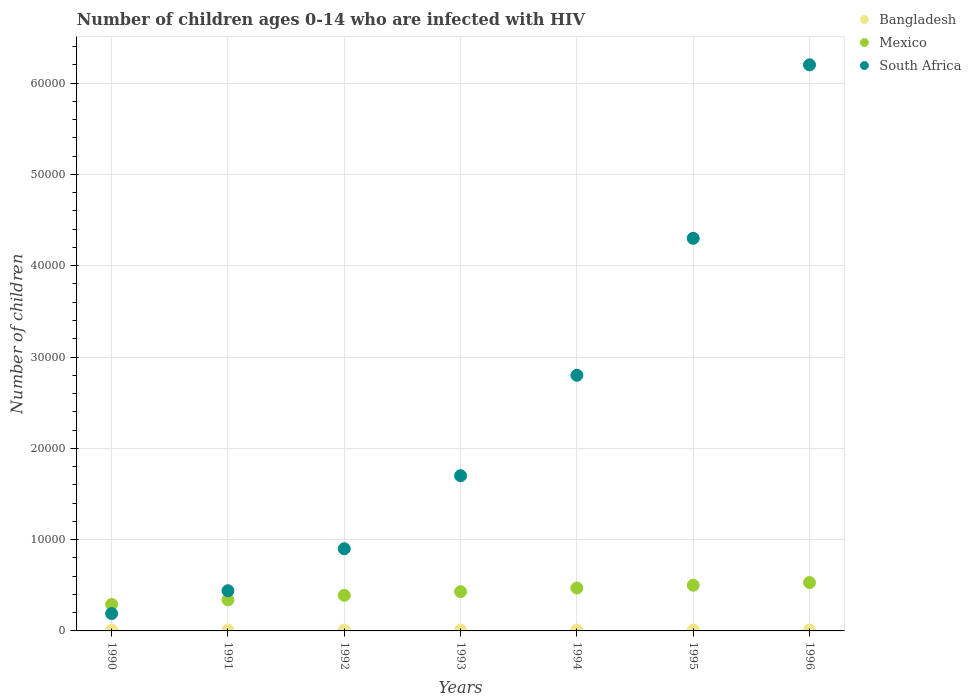What is the number of HIV infected children in South Africa in 1991?
Offer a very short reply. 4400. Across all years, what is the maximum number of HIV infected children in Mexico?
Keep it short and to the point. 5300. Across all years, what is the minimum number of HIV infected children in Bangladesh?
Offer a terse response. 100. What is the total number of HIV infected children in Bangladesh in the graph?
Make the answer very short. 700. What is the difference between the number of HIV infected children in Mexico in 1992 and that in 1995?
Your response must be concise. -1100. What is the difference between the number of HIV infected children in South Africa in 1991 and the number of HIV infected children in Mexico in 1992?
Your answer should be compact. 500. What is the average number of HIV infected children in South Africa per year?
Give a very brief answer. 2.36e+04. In the year 1994, what is the difference between the number of HIV infected children in South Africa and number of HIV infected children in Mexico?
Ensure brevity in your answer.  2.33e+04. In how many years, is the number of HIV infected children in Mexico greater than 50000?
Give a very brief answer. 0. What is the ratio of the number of HIV infected children in Bangladesh in 1990 to that in 1993?
Your answer should be very brief. 1. What is the difference between the highest and the second highest number of HIV infected children in Mexico?
Your response must be concise. 300. What is the difference between the highest and the lowest number of HIV infected children in Mexico?
Provide a short and direct response. 2400. Is the sum of the number of HIV infected children in Mexico in 1990 and 1996 greater than the maximum number of HIV infected children in South Africa across all years?
Your response must be concise. No. Is it the case that in every year, the sum of the number of HIV infected children in Mexico and number of HIV infected children in Bangladesh  is greater than the number of HIV infected children in South Africa?
Make the answer very short. No. Does the number of HIV infected children in Mexico monotonically increase over the years?
Offer a terse response. Yes. Is the number of HIV infected children in Bangladesh strictly less than the number of HIV infected children in South Africa over the years?
Your answer should be compact. Yes. Does the graph contain any zero values?
Provide a short and direct response. No. Does the graph contain grids?
Offer a terse response. Yes. Where does the legend appear in the graph?
Offer a very short reply. Top right. How many legend labels are there?
Offer a very short reply. 3. How are the legend labels stacked?
Give a very brief answer. Vertical. What is the title of the graph?
Provide a short and direct response. Number of children ages 0-14 who are infected with HIV. What is the label or title of the X-axis?
Provide a succinct answer. Years. What is the label or title of the Y-axis?
Ensure brevity in your answer.  Number of children. What is the Number of children in Bangladesh in 1990?
Your answer should be compact. 100. What is the Number of children in Mexico in 1990?
Your response must be concise. 2900. What is the Number of children of South Africa in 1990?
Offer a very short reply. 1900. What is the Number of children in Mexico in 1991?
Your answer should be very brief. 3400. What is the Number of children of South Africa in 1991?
Provide a short and direct response. 4400. What is the Number of children of Mexico in 1992?
Your answer should be very brief. 3900. What is the Number of children in South Africa in 1992?
Give a very brief answer. 9000. What is the Number of children in Bangladesh in 1993?
Provide a short and direct response. 100. What is the Number of children of Mexico in 1993?
Provide a short and direct response. 4300. What is the Number of children in South Africa in 1993?
Give a very brief answer. 1.70e+04. What is the Number of children in Bangladesh in 1994?
Offer a very short reply. 100. What is the Number of children in Mexico in 1994?
Provide a succinct answer. 4700. What is the Number of children in South Africa in 1994?
Offer a very short reply. 2.80e+04. What is the Number of children of Bangladesh in 1995?
Provide a succinct answer. 100. What is the Number of children of South Africa in 1995?
Your answer should be very brief. 4.30e+04. What is the Number of children of Mexico in 1996?
Give a very brief answer. 5300. What is the Number of children of South Africa in 1996?
Your answer should be compact. 6.20e+04. Across all years, what is the maximum Number of children of Bangladesh?
Offer a very short reply. 100. Across all years, what is the maximum Number of children of Mexico?
Your answer should be compact. 5300. Across all years, what is the maximum Number of children in South Africa?
Give a very brief answer. 6.20e+04. Across all years, what is the minimum Number of children of Bangladesh?
Keep it short and to the point. 100. Across all years, what is the minimum Number of children of Mexico?
Your answer should be very brief. 2900. Across all years, what is the minimum Number of children of South Africa?
Provide a succinct answer. 1900. What is the total Number of children of Bangladesh in the graph?
Provide a succinct answer. 700. What is the total Number of children in Mexico in the graph?
Offer a very short reply. 2.95e+04. What is the total Number of children of South Africa in the graph?
Your answer should be very brief. 1.65e+05. What is the difference between the Number of children in Mexico in 1990 and that in 1991?
Offer a very short reply. -500. What is the difference between the Number of children in South Africa in 1990 and that in 1991?
Ensure brevity in your answer.  -2500. What is the difference between the Number of children in Mexico in 1990 and that in 1992?
Give a very brief answer. -1000. What is the difference between the Number of children in South Africa in 1990 and that in 1992?
Make the answer very short. -7100. What is the difference between the Number of children in Mexico in 1990 and that in 1993?
Your answer should be compact. -1400. What is the difference between the Number of children of South Africa in 1990 and that in 1993?
Offer a very short reply. -1.51e+04. What is the difference between the Number of children of Bangladesh in 1990 and that in 1994?
Offer a terse response. 0. What is the difference between the Number of children of Mexico in 1990 and that in 1994?
Your answer should be very brief. -1800. What is the difference between the Number of children of South Africa in 1990 and that in 1994?
Provide a short and direct response. -2.61e+04. What is the difference between the Number of children in Bangladesh in 1990 and that in 1995?
Offer a very short reply. 0. What is the difference between the Number of children of Mexico in 1990 and that in 1995?
Your response must be concise. -2100. What is the difference between the Number of children of South Africa in 1990 and that in 1995?
Ensure brevity in your answer.  -4.11e+04. What is the difference between the Number of children in Mexico in 1990 and that in 1996?
Make the answer very short. -2400. What is the difference between the Number of children of South Africa in 1990 and that in 1996?
Provide a short and direct response. -6.01e+04. What is the difference between the Number of children in Mexico in 1991 and that in 1992?
Keep it short and to the point. -500. What is the difference between the Number of children of South Africa in 1991 and that in 1992?
Your answer should be very brief. -4600. What is the difference between the Number of children in Bangladesh in 1991 and that in 1993?
Offer a very short reply. 0. What is the difference between the Number of children of Mexico in 1991 and that in 1993?
Offer a terse response. -900. What is the difference between the Number of children in South Africa in 1991 and that in 1993?
Ensure brevity in your answer.  -1.26e+04. What is the difference between the Number of children of Bangladesh in 1991 and that in 1994?
Your response must be concise. 0. What is the difference between the Number of children in Mexico in 1991 and that in 1994?
Make the answer very short. -1300. What is the difference between the Number of children of South Africa in 1991 and that in 1994?
Your answer should be compact. -2.36e+04. What is the difference between the Number of children of Mexico in 1991 and that in 1995?
Ensure brevity in your answer.  -1600. What is the difference between the Number of children in South Africa in 1991 and that in 1995?
Keep it short and to the point. -3.86e+04. What is the difference between the Number of children in Bangladesh in 1991 and that in 1996?
Ensure brevity in your answer.  0. What is the difference between the Number of children of Mexico in 1991 and that in 1996?
Provide a short and direct response. -1900. What is the difference between the Number of children of South Africa in 1991 and that in 1996?
Ensure brevity in your answer.  -5.76e+04. What is the difference between the Number of children of Mexico in 1992 and that in 1993?
Offer a terse response. -400. What is the difference between the Number of children in South Africa in 1992 and that in 1993?
Your response must be concise. -8000. What is the difference between the Number of children in Bangladesh in 1992 and that in 1994?
Your answer should be very brief. 0. What is the difference between the Number of children in Mexico in 1992 and that in 1994?
Make the answer very short. -800. What is the difference between the Number of children in South Africa in 1992 and that in 1994?
Offer a very short reply. -1.90e+04. What is the difference between the Number of children of Mexico in 1992 and that in 1995?
Keep it short and to the point. -1100. What is the difference between the Number of children of South Africa in 1992 and that in 1995?
Offer a terse response. -3.40e+04. What is the difference between the Number of children of Mexico in 1992 and that in 1996?
Your response must be concise. -1400. What is the difference between the Number of children in South Africa in 1992 and that in 1996?
Provide a short and direct response. -5.30e+04. What is the difference between the Number of children in Bangladesh in 1993 and that in 1994?
Make the answer very short. 0. What is the difference between the Number of children of Mexico in 1993 and that in 1994?
Your answer should be compact. -400. What is the difference between the Number of children in South Africa in 1993 and that in 1994?
Give a very brief answer. -1.10e+04. What is the difference between the Number of children in Bangladesh in 1993 and that in 1995?
Your response must be concise. 0. What is the difference between the Number of children of Mexico in 1993 and that in 1995?
Provide a succinct answer. -700. What is the difference between the Number of children in South Africa in 1993 and that in 1995?
Ensure brevity in your answer.  -2.60e+04. What is the difference between the Number of children of Mexico in 1993 and that in 1996?
Your response must be concise. -1000. What is the difference between the Number of children of South Africa in 1993 and that in 1996?
Provide a short and direct response. -4.50e+04. What is the difference between the Number of children in Bangladesh in 1994 and that in 1995?
Your response must be concise. 0. What is the difference between the Number of children in Mexico in 1994 and that in 1995?
Ensure brevity in your answer.  -300. What is the difference between the Number of children in South Africa in 1994 and that in 1995?
Provide a succinct answer. -1.50e+04. What is the difference between the Number of children of Mexico in 1994 and that in 1996?
Offer a very short reply. -600. What is the difference between the Number of children of South Africa in 1994 and that in 1996?
Your response must be concise. -3.40e+04. What is the difference between the Number of children in Bangladesh in 1995 and that in 1996?
Offer a terse response. 0. What is the difference between the Number of children of Mexico in 1995 and that in 1996?
Offer a very short reply. -300. What is the difference between the Number of children of South Africa in 1995 and that in 1996?
Provide a succinct answer. -1.90e+04. What is the difference between the Number of children in Bangladesh in 1990 and the Number of children in Mexico in 1991?
Provide a short and direct response. -3300. What is the difference between the Number of children in Bangladesh in 1990 and the Number of children in South Africa in 1991?
Offer a terse response. -4300. What is the difference between the Number of children in Mexico in 1990 and the Number of children in South Africa in 1991?
Ensure brevity in your answer.  -1500. What is the difference between the Number of children of Bangladesh in 1990 and the Number of children of Mexico in 1992?
Provide a succinct answer. -3800. What is the difference between the Number of children of Bangladesh in 1990 and the Number of children of South Africa in 1992?
Your response must be concise. -8900. What is the difference between the Number of children in Mexico in 1990 and the Number of children in South Africa in 1992?
Give a very brief answer. -6100. What is the difference between the Number of children in Bangladesh in 1990 and the Number of children in Mexico in 1993?
Provide a succinct answer. -4200. What is the difference between the Number of children of Bangladesh in 1990 and the Number of children of South Africa in 1993?
Give a very brief answer. -1.69e+04. What is the difference between the Number of children in Mexico in 1990 and the Number of children in South Africa in 1993?
Offer a terse response. -1.41e+04. What is the difference between the Number of children in Bangladesh in 1990 and the Number of children in Mexico in 1994?
Your answer should be very brief. -4600. What is the difference between the Number of children in Bangladesh in 1990 and the Number of children in South Africa in 1994?
Your answer should be very brief. -2.79e+04. What is the difference between the Number of children of Mexico in 1990 and the Number of children of South Africa in 1994?
Provide a short and direct response. -2.51e+04. What is the difference between the Number of children of Bangladesh in 1990 and the Number of children of Mexico in 1995?
Give a very brief answer. -4900. What is the difference between the Number of children in Bangladesh in 1990 and the Number of children in South Africa in 1995?
Provide a short and direct response. -4.29e+04. What is the difference between the Number of children of Mexico in 1990 and the Number of children of South Africa in 1995?
Offer a terse response. -4.01e+04. What is the difference between the Number of children in Bangladesh in 1990 and the Number of children in Mexico in 1996?
Offer a very short reply. -5200. What is the difference between the Number of children in Bangladesh in 1990 and the Number of children in South Africa in 1996?
Give a very brief answer. -6.19e+04. What is the difference between the Number of children of Mexico in 1990 and the Number of children of South Africa in 1996?
Your answer should be compact. -5.91e+04. What is the difference between the Number of children in Bangladesh in 1991 and the Number of children in Mexico in 1992?
Give a very brief answer. -3800. What is the difference between the Number of children in Bangladesh in 1991 and the Number of children in South Africa in 1992?
Provide a succinct answer. -8900. What is the difference between the Number of children in Mexico in 1991 and the Number of children in South Africa in 1992?
Your answer should be compact. -5600. What is the difference between the Number of children in Bangladesh in 1991 and the Number of children in Mexico in 1993?
Give a very brief answer. -4200. What is the difference between the Number of children of Bangladesh in 1991 and the Number of children of South Africa in 1993?
Ensure brevity in your answer.  -1.69e+04. What is the difference between the Number of children in Mexico in 1991 and the Number of children in South Africa in 1993?
Provide a short and direct response. -1.36e+04. What is the difference between the Number of children of Bangladesh in 1991 and the Number of children of Mexico in 1994?
Provide a succinct answer. -4600. What is the difference between the Number of children of Bangladesh in 1991 and the Number of children of South Africa in 1994?
Offer a terse response. -2.79e+04. What is the difference between the Number of children of Mexico in 1991 and the Number of children of South Africa in 1994?
Offer a terse response. -2.46e+04. What is the difference between the Number of children in Bangladesh in 1991 and the Number of children in Mexico in 1995?
Offer a terse response. -4900. What is the difference between the Number of children of Bangladesh in 1991 and the Number of children of South Africa in 1995?
Offer a terse response. -4.29e+04. What is the difference between the Number of children of Mexico in 1991 and the Number of children of South Africa in 1995?
Provide a succinct answer. -3.96e+04. What is the difference between the Number of children in Bangladesh in 1991 and the Number of children in Mexico in 1996?
Your answer should be compact. -5200. What is the difference between the Number of children of Bangladesh in 1991 and the Number of children of South Africa in 1996?
Make the answer very short. -6.19e+04. What is the difference between the Number of children in Mexico in 1991 and the Number of children in South Africa in 1996?
Your answer should be very brief. -5.86e+04. What is the difference between the Number of children of Bangladesh in 1992 and the Number of children of Mexico in 1993?
Offer a terse response. -4200. What is the difference between the Number of children of Bangladesh in 1992 and the Number of children of South Africa in 1993?
Offer a terse response. -1.69e+04. What is the difference between the Number of children of Mexico in 1992 and the Number of children of South Africa in 1993?
Offer a terse response. -1.31e+04. What is the difference between the Number of children in Bangladesh in 1992 and the Number of children in Mexico in 1994?
Offer a terse response. -4600. What is the difference between the Number of children of Bangladesh in 1992 and the Number of children of South Africa in 1994?
Provide a succinct answer. -2.79e+04. What is the difference between the Number of children of Mexico in 1992 and the Number of children of South Africa in 1994?
Provide a succinct answer. -2.41e+04. What is the difference between the Number of children in Bangladesh in 1992 and the Number of children in Mexico in 1995?
Your response must be concise. -4900. What is the difference between the Number of children of Bangladesh in 1992 and the Number of children of South Africa in 1995?
Make the answer very short. -4.29e+04. What is the difference between the Number of children of Mexico in 1992 and the Number of children of South Africa in 1995?
Offer a very short reply. -3.91e+04. What is the difference between the Number of children of Bangladesh in 1992 and the Number of children of Mexico in 1996?
Offer a terse response. -5200. What is the difference between the Number of children in Bangladesh in 1992 and the Number of children in South Africa in 1996?
Your answer should be very brief. -6.19e+04. What is the difference between the Number of children in Mexico in 1992 and the Number of children in South Africa in 1996?
Your answer should be very brief. -5.81e+04. What is the difference between the Number of children of Bangladesh in 1993 and the Number of children of Mexico in 1994?
Make the answer very short. -4600. What is the difference between the Number of children in Bangladesh in 1993 and the Number of children in South Africa in 1994?
Make the answer very short. -2.79e+04. What is the difference between the Number of children in Mexico in 1993 and the Number of children in South Africa in 1994?
Make the answer very short. -2.37e+04. What is the difference between the Number of children in Bangladesh in 1993 and the Number of children in Mexico in 1995?
Provide a succinct answer. -4900. What is the difference between the Number of children in Bangladesh in 1993 and the Number of children in South Africa in 1995?
Ensure brevity in your answer.  -4.29e+04. What is the difference between the Number of children of Mexico in 1993 and the Number of children of South Africa in 1995?
Your response must be concise. -3.87e+04. What is the difference between the Number of children of Bangladesh in 1993 and the Number of children of Mexico in 1996?
Provide a succinct answer. -5200. What is the difference between the Number of children in Bangladesh in 1993 and the Number of children in South Africa in 1996?
Your response must be concise. -6.19e+04. What is the difference between the Number of children in Mexico in 1993 and the Number of children in South Africa in 1996?
Your response must be concise. -5.77e+04. What is the difference between the Number of children of Bangladesh in 1994 and the Number of children of Mexico in 1995?
Provide a short and direct response. -4900. What is the difference between the Number of children of Bangladesh in 1994 and the Number of children of South Africa in 1995?
Give a very brief answer. -4.29e+04. What is the difference between the Number of children in Mexico in 1994 and the Number of children in South Africa in 1995?
Provide a succinct answer. -3.83e+04. What is the difference between the Number of children of Bangladesh in 1994 and the Number of children of Mexico in 1996?
Your response must be concise. -5200. What is the difference between the Number of children of Bangladesh in 1994 and the Number of children of South Africa in 1996?
Your answer should be compact. -6.19e+04. What is the difference between the Number of children of Mexico in 1994 and the Number of children of South Africa in 1996?
Offer a very short reply. -5.73e+04. What is the difference between the Number of children of Bangladesh in 1995 and the Number of children of Mexico in 1996?
Your answer should be compact. -5200. What is the difference between the Number of children of Bangladesh in 1995 and the Number of children of South Africa in 1996?
Provide a short and direct response. -6.19e+04. What is the difference between the Number of children of Mexico in 1995 and the Number of children of South Africa in 1996?
Provide a succinct answer. -5.70e+04. What is the average Number of children in Mexico per year?
Ensure brevity in your answer.  4214.29. What is the average Number of children of South Africa per year?
Offer a terse response. 2.36e+04. In the year 1990, what is the difference between the Number of children of Bangladesh and Number of children of Mexico?
Ensure brevity in your answer.  -2800. In the year 1990, what is the difference between the Number of children of Bangladesh and Number of children of South Africa?
Your response must be concise. -1800. In the year 1990, what is the difference between the Number of children of Mexico and Number of children of South Africa?
Your answer should be very brief. 1000. In the year 1991, what is the difference between the Number of children in Bangladesh and Number of children in Mexico?
Provide a succinct answer. -3300. In the year 1991, what is the difference between the Number of children in Bangladesh and Number of children in South Africa?
Your answer should be very brief. -4300. In the year 1991, what is the difference between the Number of children in Mexico and Number of children in South Africa?
Offer a very short reply. -1000. In the year 1992, what is the difference between the Number of children in Bangladesh and Number of children in Mexico?
Provide a short and direct response. -3800. In the year 1992, what is the difference between the Number of children in Bangladesh and Number of children in South Africa?
Give a very brief answer. -8900. In the year 1992, what is the difference between the Number of children in Mexico and Number of children in South Africa?
Ensure brevity in your answer.  -5100. In the year 1993, what is the difference between the Number of children in Bangladesh and Number of children in Mexico?
Your answer should be compact. -4200. In the year 1993, what is the difference between the Number of children in Bangladesh and Number of children in South Africa?
Keep it short and to the point. -1.69e+04. In the year 1993, what is the difference between the Number of children in Mexico and Number of children in South Africa?
Give a very brief answer. -1.27e+04. In the year 1994, what is the difference between the Number of children in Bangladesh and Number of children in Mexico?
Your answer should be very brief. -4600. In the year 1994, what is the difference between the Number of children in Bangladesh and Number of children in South Africa?
Make the answer very short. -2.79e+04. In the year 1994, what is the difference between the Number of children of Mexico and Number of children of South Africa?
Ensure brevity in your answer.  -2.33e+04. In the year 1995, what is the difference between the Number of children of Bangladesh and Number of children of Mexico?
Your answer should be very brief. -4900. In the year 1995, what is the difference between the Number of children of Bangladesh and Number of children of South Africa?
Your answer should be very brief. -4.29e+04. In the year 1995, what is the difference between the Number of children of Mexico and Number of children of South Africa?
Ensure brevity in your answer.  -3.80e+04. In the year 1996, what is the difference between the Number of children of Bangladesh and Number of children of Mexico?
Give a very brief answer. -5200. In the year 1996, what is the difference between the Number of children in Bangladesh and Number of children in South Africa?
Give a very brief answer. -6.19e+04. In the year 1996, what is the difference between the Number of children of Mexico and Number of children of South Africa?
Ensure brevity in your answer.  -5.67e+04. What is the ratio of the Number of children in Mexico in 1990 to that in 1991?
Your response must be concise. 0.85. What is the ratio of the Number of children in South Africa in 1990 to that in 1991?
Your response must be concise. 0.43. What is the ratio of the Number of children of Bangladesh in 1990 to that in 1992?
Your answer should be compact. 1. What is the ratio of the Number of children of Mexico in 1990 to that in 1992?
Provide a succinct answer. 0.74. What is the ratio of the Number of children of South Africa in 1990 to that in 1992?
Ensure brevity in your answer.  0.21. What is the ratio of the Number of children in Bangladesh in 1990 to that in 1993?
Offer a terse response. 1. What is the ratio of the Number of children of Mexico in 1990 to that in 1993?
Give a very brief answer. 0.67. What is the ratio of the Number of children of South Africa in 1990 to that in 1993?
Your answer should be compact. 0.11. What is the ratio of the Number of children in Bangladesh in 1990 to that in 1994?
Your response must be concise. 1. What is the ratio of the Number of children of Mexico in 1990 to that in 1994?
Provide a short and direct response. 0.62. What is the ratio of the Number of children in South Africa in 1990 to that in 1994?
Your response must be concise. 0.07. What is the ratio of the Number of children of Mexico in 1990 to that in 1995?
Give a very brief answer. 0.58. What is the ratio of the Number of children of South Africa in 1990 to that in 1995?
Keep it short and to the point. 0.04. What is the ratio of the Number of children of Bangladesh in 1990 to that in 1996?
Your response must be concise. 1. What is the ratio of the Number of children in Mexico in 1990 to that in 1996?
Ensure brevity in your answer.  0.55. What is the ratio of the Number of children in South Africa in 1990 to that in 1996?
Your answer should be compact. 0.03. What is the ratio of the Number of children of Bangladesh in 1991 to that in 1992?
Your answer should be compact. 1. What is the ratio of the Number of children in Mexico in 1991 to that in 1992?
Provide a short and direct response. 0.87. What is the ratio of the Number of children of South Africa in 1991 to that in 1992?
Give a very brief answer. 0.49. What is the ratio of the Number of children in Bangladesh in 1991 to that in 1993?
Provide a short and direct response. 1. What is the ratio of the Number of children in Mexico in 1991 to that in 1993?
Provide a short and direct response. 0.79. What is the ratio of the Number of children in South Africa in 1991 to that in 1993?
Your response must be concise. 0.26. What is the ratio of the Number of children of Mexico in 1991 to that in 1994?
Offer a very short reply. 0.72. What is the ratio of the Number of children in South Africa in 1991 to that in 1994?
Ensure brevity in your answer.  0.16. What is the ratio of the Number of children in Mexico in 1991 to that in 1995?
Ensure brevity in your answer.  0.68. What is the ratio of the Number of children in South Africa in 1991 to that in 1995?
Your answer should be very brief. 0.1. What is the ratio of the Number of children of Bangladesh in 1991 to that in 1996?
Give a very brief answer. 1. What is the ratio of the Number of children in Mexico in 1991 to that in 1996?
Ensure brevity in your answer.  0.64. What is the ratio of the Number of children of South Africa in 1991 to that in 1996?
Ensure brevity in your answer.  0.07. What is the ratio of the Number of children in Mexico in 1992 to that in 1993?
Offer a terse response. 0.91. What is the ratio of the Number of children in South Africa in 1992 to that in 1993?
Make the answer very short. 0.53. What is the ratio of the Number of children of Mexico in 1992 to that in 1994?
Provide a short and direct response. 0.83. What is the ratio of the Number of children in South Africa in 1992 to that in 1994?
Offer a terse response. 0.32. What is the ratio of the Number of children in Mexico in 1992 to that in 1995?
Offer a terse response. 0.78. What is the ratio of the Number of children in South Africa in 1992 to that in 1995?
Make the answer very short. 0.21. What is the ratio of the Number of children of Bangladesh in 1992 to that in 1996?
Your answer should be very brief. 1. What is the ratio of the Number of children in Mexico in 1992 to that in 1996?
Keep it short and to the point. 0.74. What is the ratio of the Number of children of South Africa in 1992 to that in 1996?
Offer a terse response. 0.15. What is the ratio of the Number of children in Bangladesh in 1993 to that in 1994?
Keep it short and to the point. 1. What is the ratio of the Number of children of Mexico in 1993 to that in 1994?
Offer a terse response. 0.91. What is the ratio of the Number of children of South Africa in 1993 to that in 1994?
Ensure brevity in your answer.  0.61. What is the ratio of the Number of children of Bangladesh in 1993 to that in 1995?
Offer a terse response. 1. What is the ratio of the Number of children of Mexico in 1993 to that in 1995?
Make the answer very short. 0.86. What is the ratio of the Number of children of South Africa in 1993 to that in 1995?
Your answer should be very brief. 0.4. What is the ratio of the Number of children of Bangladesh in 1993 to that in 1996?
Offer a very short reply. 1. What is the ratio of the Number of children in Mexico in 1993 to that in 1996?
Your answer should be very brief. 0.81. What is the ratio of the Number of children of South Africa in 1993 to that in 1996?
Make the answer very short. 0.27. What is the ratio of the Number of children in Bangladesh in 1994 to that in 1995?
Provide a succinct answer. 1. What is the ratio of the Number of children in Mexico in 1994 to that in 1995?
Offer a very short reply. 0.94. What is the ratio of the Number of children of South Africa in 1994 to that in 1995?
Offer a terse response. 0.65. What is the ratio of the Number of children of Mexico in 1994 to that in 1996?
Give a very brief answer. 0.89. What is the ratio of the Number of children in South Africa in 1994 to that in 1996?
Keep it short and to the point. 0.45. What is the ratio of the Number of children of Mexico in 1995 to that in 1996?
Offer a terse response. 0.94. What is the ratio of the Number of children in South Africa in 1995 to that in 1996?
Keep it short and to the point. 0.69. What is the difference between the highest and the second highest Number of children of Bangladesh?
Keep it short and to the point. 0. What is the difference between the highest and the second highest Number of children in Mexico?
Keep it short and to the point. 300. What is the difference between the highest and the second highest Number of children of South Africa?
Ensure brevity in your answer.  1.90e+04. What is the difference between the highest and the lowest Number of children in Mexico?
Ensure brevity in your answer.  2400. What is the difference between the highest and the lowest Number of children of South Africa?
Make the answer very short. 6.01e+04. 